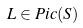<formula> <loc_0><loc_0><loc_500><loc_500>L \in { P i c } ( S )</formula> 